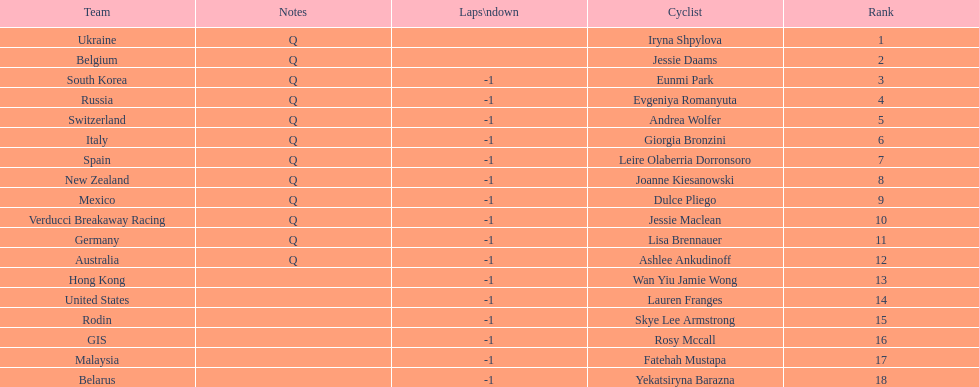What team is listed previous to belgium? Ukraine. 